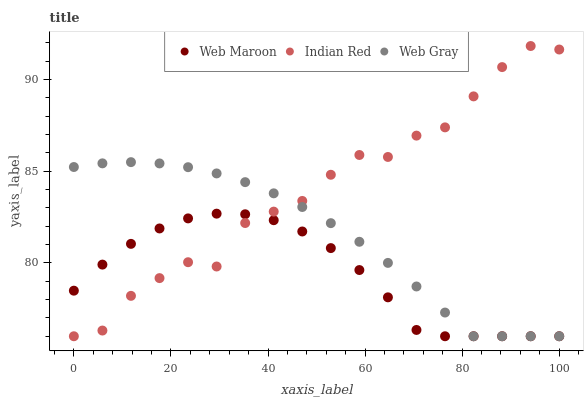Does Web Maroon have the minimum area under the curve?
Answer yes or no. Yes. Does Indian Red have the maximum area under the curve?
Answer yes or no. Yes. Does Indian Red have the minimum area under the curve?
Answer yes or no. No. Does Web Maroon have the maximum area under the curve?
Answer yes or no. No. Is Web Gray the smoothest?
Answer yes or no. Yes. Is Indian Red the roughest?
Answer yes or no. Yes. Is Web Maroon the smoothest?
Answer yes or no. No. Is Web Maroon the roughest?
Answer yes or no. No. Does Web Gray have the lowest value?
Answer yes or no. Yes. Does Indian Red have the highest value?
Answer yes or no. Yes. Does Web Maroon have the highest value?
Answer yes or no. No. Does Web Maroon intersect Indian Red?
Answer yes or no. Yes. Is Web Maroon less than Indian Red?
Answer yes or no. No. Is Web Maroon greater than Indian Red?
Answer yes or no. No. 